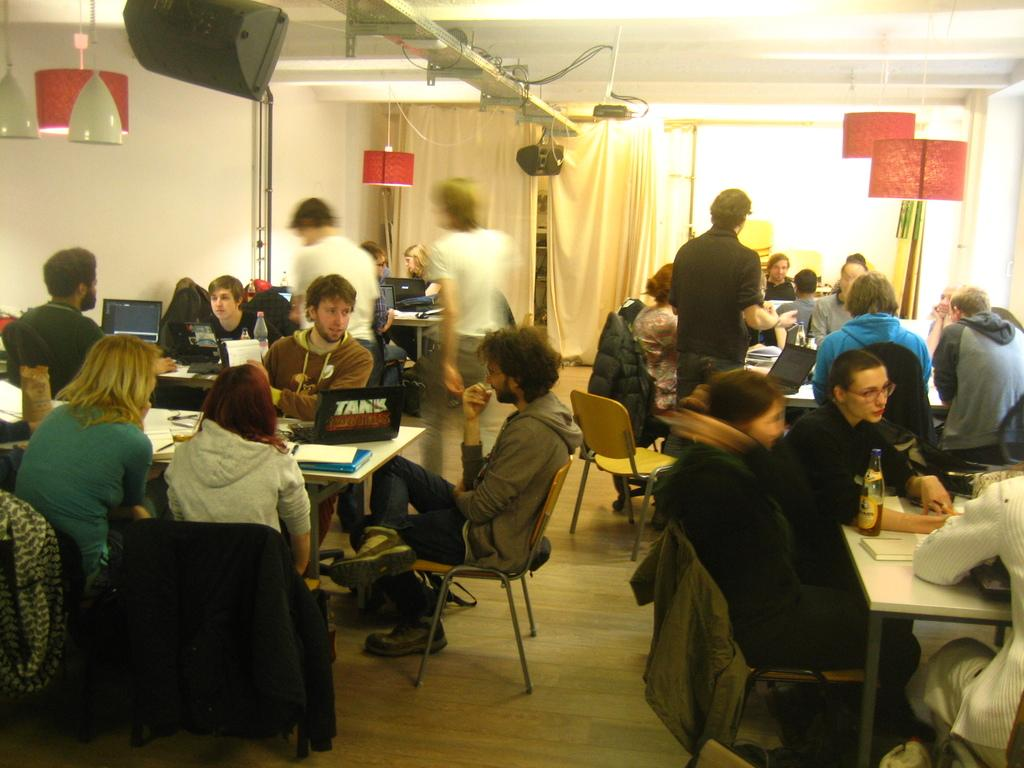What are the people in the image doing? People are sitting in groups at tables and some are standing. Can you describe the lighting in the image? Lights are hanging from the roof, and they have a red color covering. What type of pest can be seen crawling on the table in the image? There is no pest visible on the table in the image. What kind of insurance policy is being discussed by the people in the image? There is no indication in the image that the people are discussing any insurance policies. 